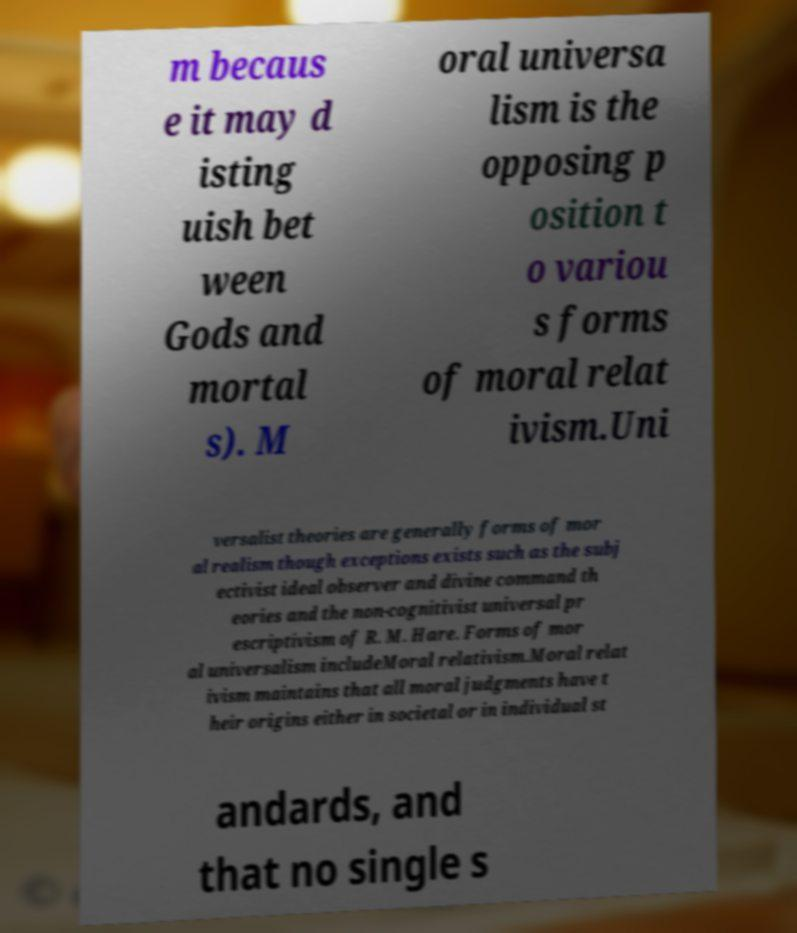Could you assist in decoding the text presented in this image and type it out clearly? m becaus e it may d isting uish bet ween Gods and mortal s). M oral universa lism is the opposing p osition t o variou s forms of moral relat ivism.Uni versalist theories are generally forms of mor al realism though exceptions exists such as the subj ectivist ideal observer and divine command th eories and the non-cognitivist universal pr escriptivism of R. M. Hare. Forms of mor al universalism includeMoral relativism.Moral relat ivism maintains that all moral judgments have t heir origins either in societal or in individual st andards, and that no single s 